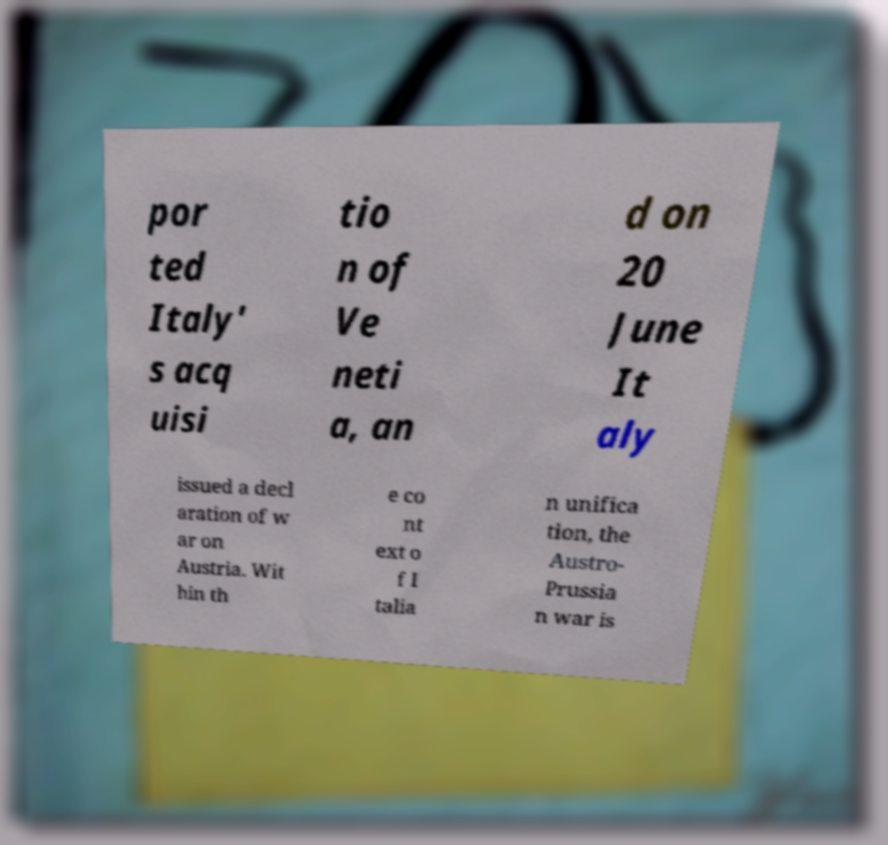For documentation purposes, I need the text within this image transcribed. Could you provide that? por ted Italy' s acq uisi tio n of Ve neti a, an d on 20 June It aly issued a decl aration of w ar on Austria. Wit hin th e co nt ext o f I talia n unifica tion, the Austro- Prussia n war is 